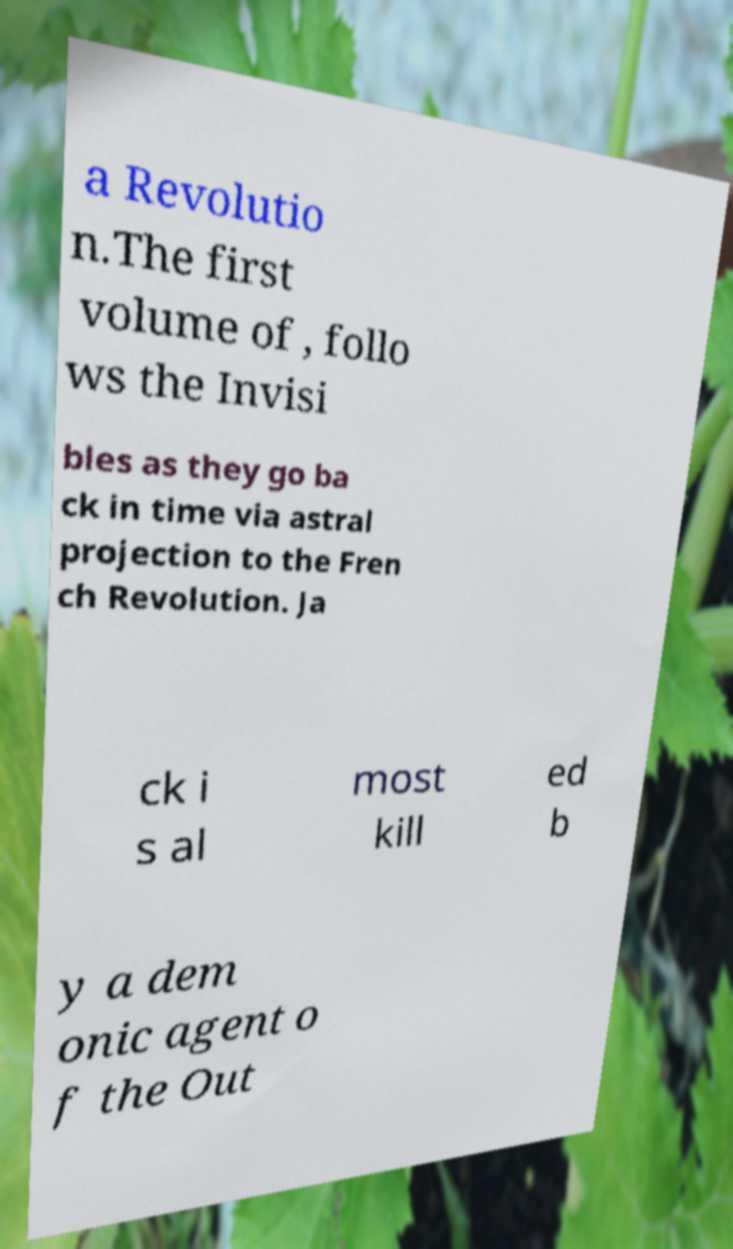Could you extract and type out the text from this image? a Revolutio n.The first volume of , follo ws the Invisi bles as they go ba ck in time via astral projection to the Fren ch Revolution. Ja ck i s al most kill ed b y a dem onic agent o f the Out 